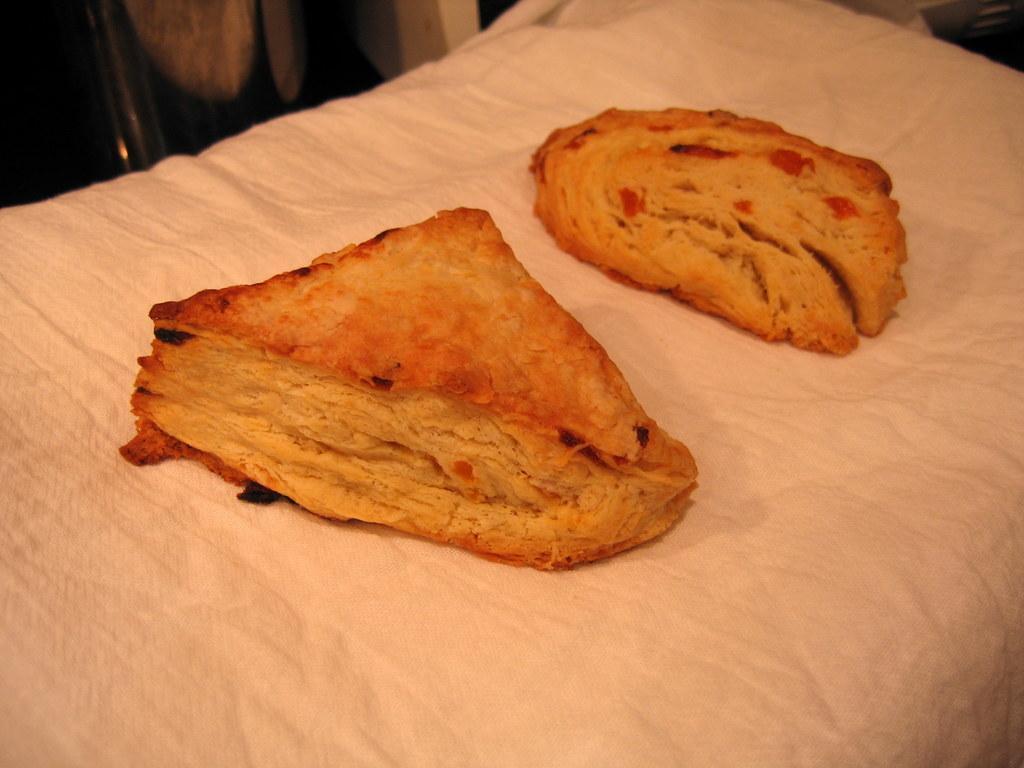Please provide a concise description of this image. In this image I can see there are two bread pieces might be kept on cloth in the middle. 